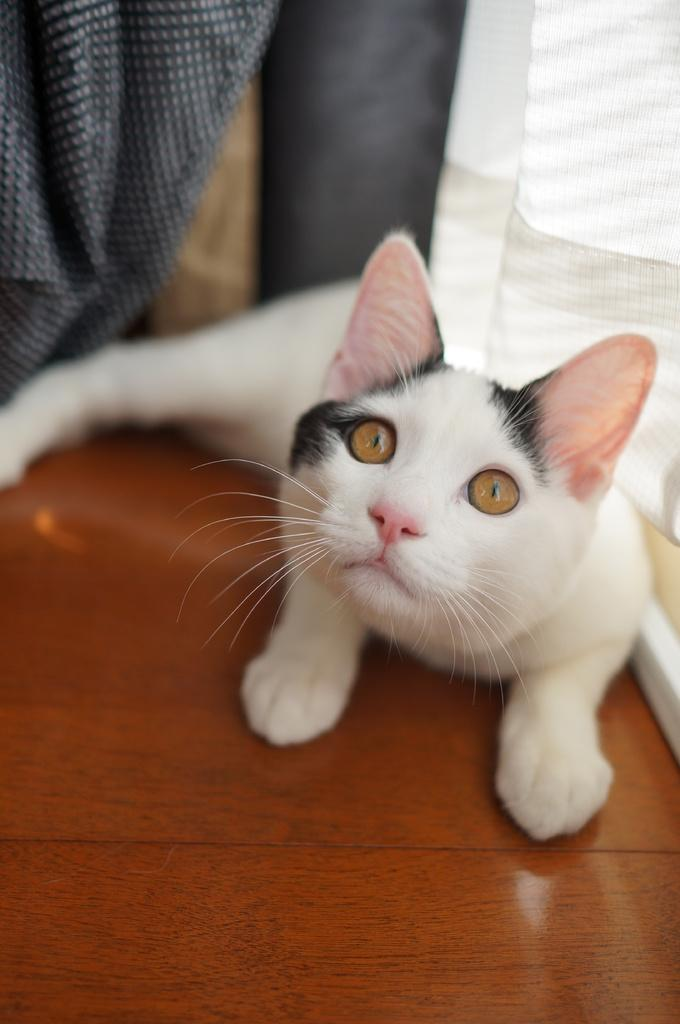What type of animal is in the image? There is a white color cat in the image. What is the cat sitting on? The cat is on a wooden surface. What can be seen in the background of the image? There are clothes and other objects in the background of the image. Is the cat playing with a ball in the image? There is no ball present in the image, so it cannot be determined if the cat is playing with one. 